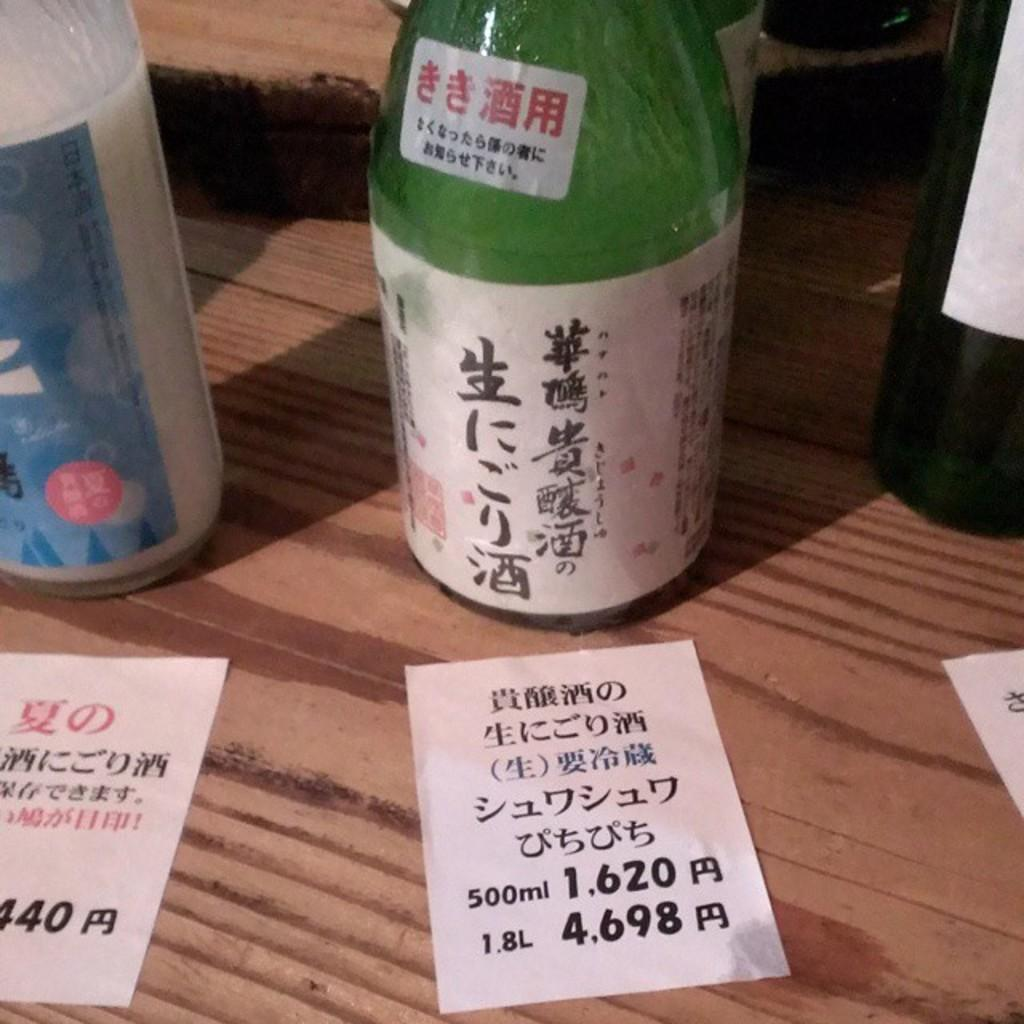What objects are on the table in the image? There are bottles and paper notes on the table. Can you describe the bottles on the table? The provided facts do not give any specific details about the bottles, so we cannot describe them further. What might the paper notes be used for? The paper notes on the table might be used for writing or taking notes. What type of mine is visible in the image? There is no mine present in the image; it only features bottles and paper notes on a table. 